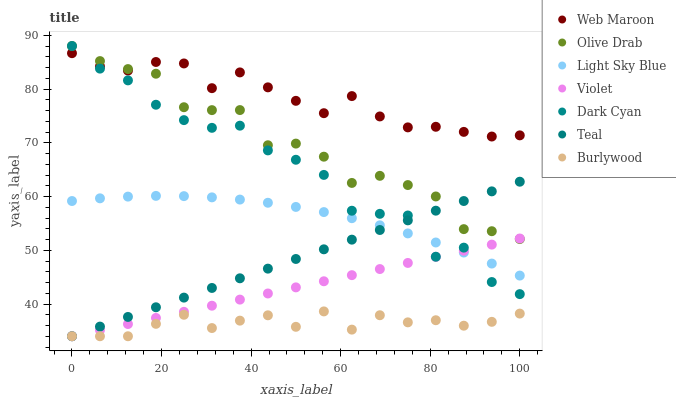Does Burlywood have the minimum area under the curve?
Answer yes or no. Yes. Does Web Maroon have the maximum area under the curve?
Answer yes or no. Yes. Does Light Sky Blue have the minimum area under the curve?
Answer yes or no. No. Does Light Sky Blue have the maximum area under the curve?
Answer yes or no. No. Is Violet the smoothest?
Answer yes or no. Yes. Is Dark Cyan the roughest?
Answer yes or no. Yes. Is Web Maroon the smoothest?
Answer yes or no. No. Is Web Maroon the roughest?
Answer yes or no. No. Does Burlywood have the lowest value?
Answer yes or no. Yes. Does Light Sky Blue have the lowest value?
Answer yes or no. No. Does Olive Drab have the highest value?
Answer yes or no. Yes. Does Web Maroon have the highest value?
Answer yes or no. No. Is Burlywood less than Web Maroon?
Answer yes or no. Yes. Is Olive Drab greater than Burlywood?
Answer yes or no. Yes. Does Dark Cyan intersect Light Sky Blue?
Answer yes or no. Yes. Is Dark Cyan less than Light Sky Blue?
Answer yes or no. No. Is Dark Cyan greater than Light Sky Blue?
Answer yes or no. No. Does Burlywood intersect Web Maroon?
Answer yes or no. No. 